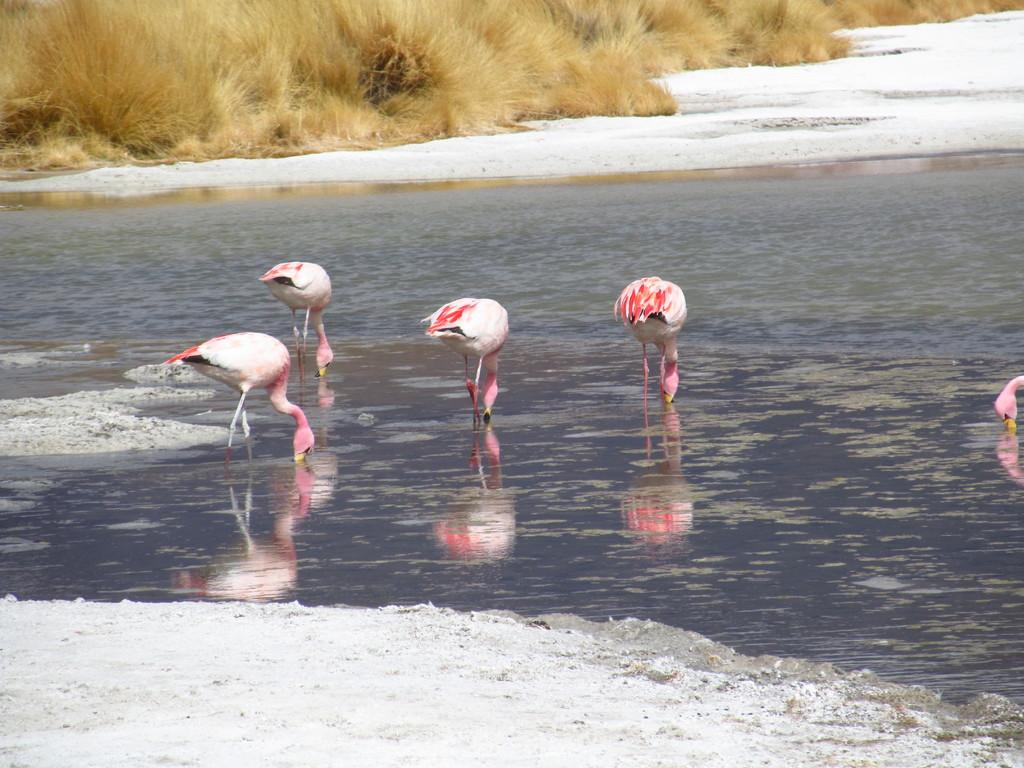What type of animals can be seen in the water in the image? There are birds in the water in the image. What type of vegetation is visible at the top of the image? There is dry grass at the top of the image. What type of butter can be seen on the giraffe's head in the image? There is no giraffe or butter present in the image; it features birds in the water and dry grass at the top. 